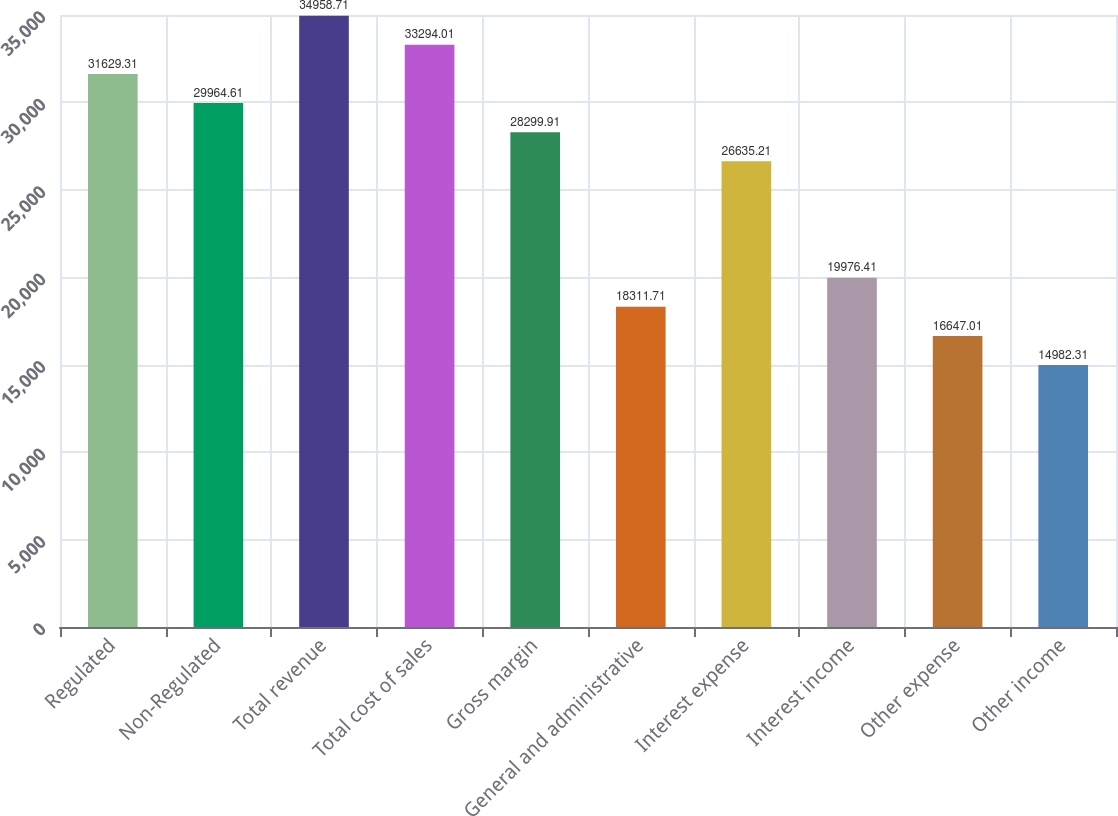Convert chart to OTSL. <chart><loc_0><loc_0><loc_500><loc_500><bar_chart><fcel>Regulated<fcel>Non-Regulated<fcel>Total revenue<fcel>Total cost of sales<fcel>Gross margin<fcel>General and administrative<fcel>Interest expense<fcel>Interest income<fcel>Other expense<fcel>Other income<nl><fcel>31629.3<fcel>29964.6<fcel>34958.7<fcel>33294<fcel>28299.9<fcel>18311.7<fcel>26635.2<fcel>19976.4<fcel>16647<fcel>14982.3<nl></chart> 